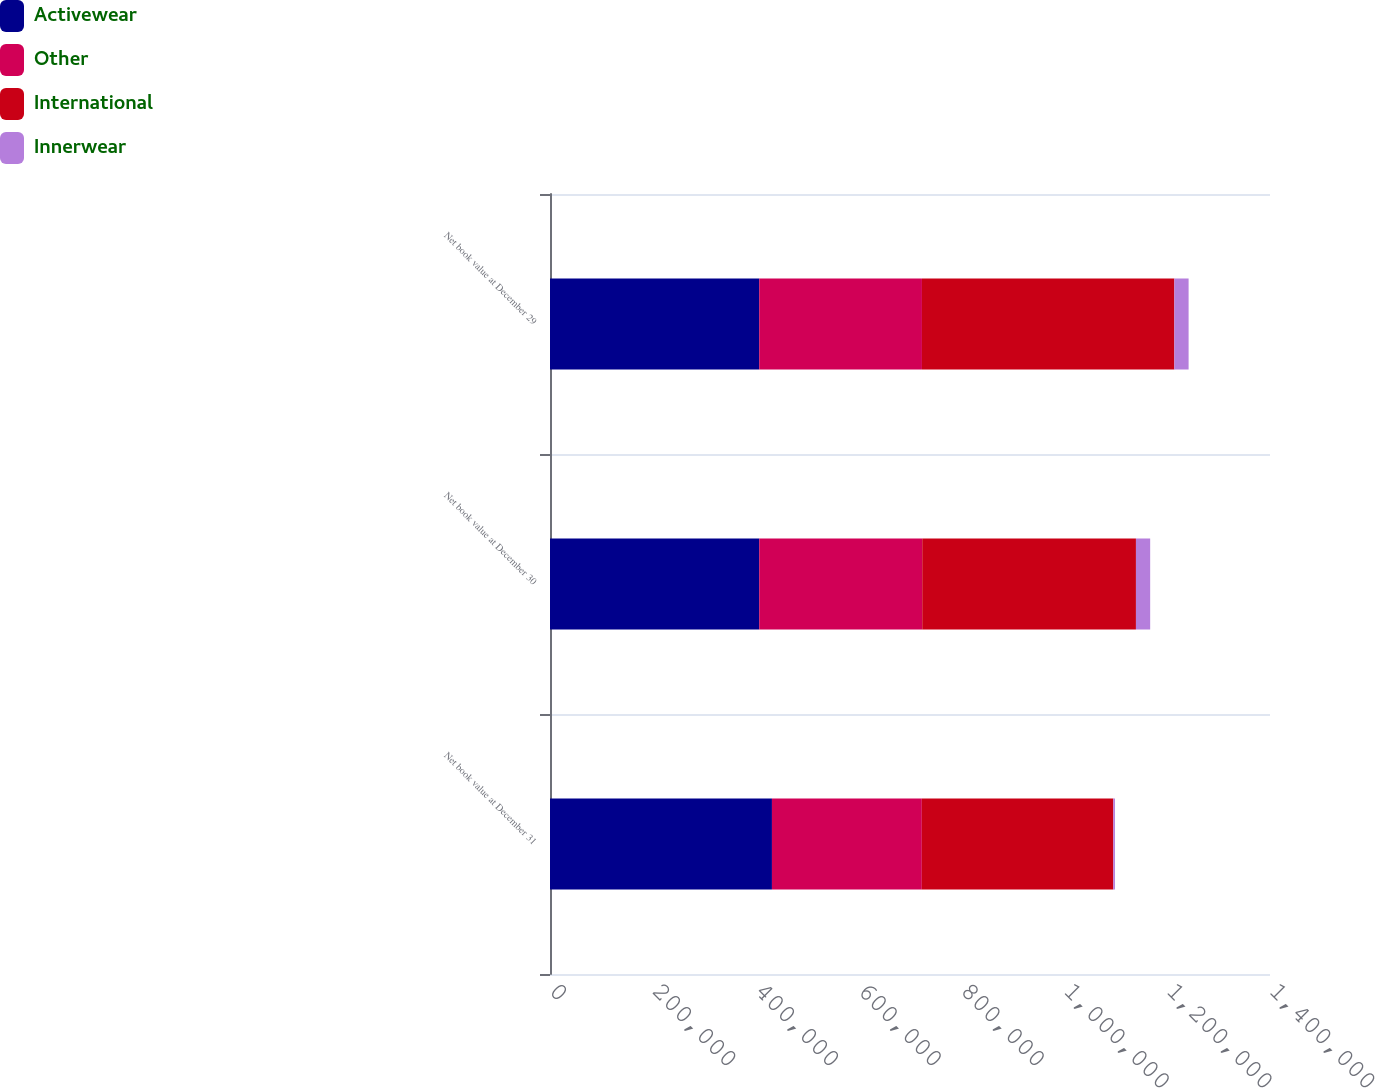Convert chart to OTSL. <chart><loc_0><loc_0><loc_500><loc_500><stacked_bar_chart><ecel><fcel>Net book value at December 31<fcel>Net book value at December 30<fcel>Net book value at December 29<nl><fcel>Activewear<fcel>431561<fcel>406853<fcel>406853<nl><fcel>Other<fcel>291443<fcel>316950<fcel>316384<nl><fcel>International<fcel>372312<fcel>415531<fcel>490817<nl><fcel>Innerwear<fcel>3224<fcel>27673<fcel>27673<nl></chart> 